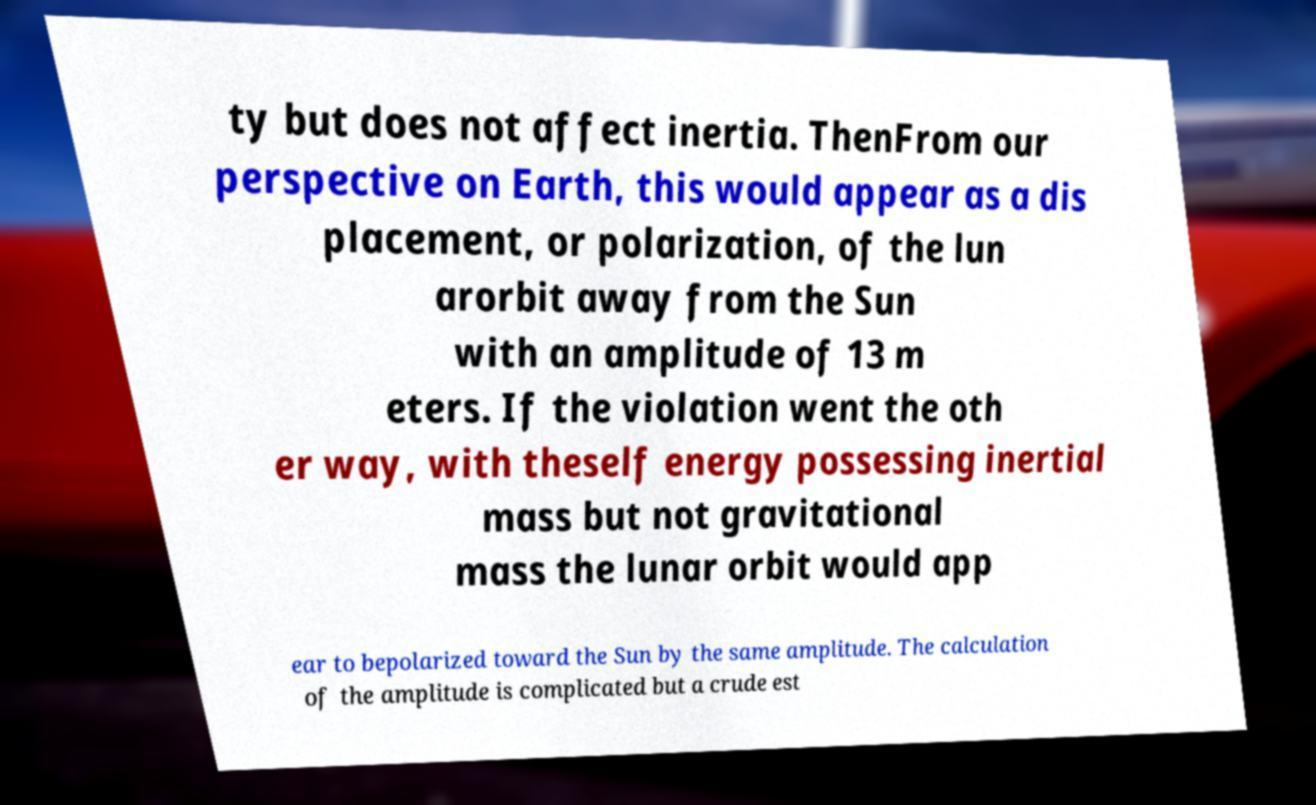For documentation purposes, I need the text within this image transcribed. Could you provide that? ty but does not affect inertia. ThenFrom our perspective on Earth, this would appear as a dis placement, or polarization, of the lun arorbit away from the Sun with an amplitude of 13 m eters. If the violation went the oth er way, with theself energy possessing inertial mass but not gravitational mass the lunar orbit would app ear to bepolarized toward the Sun by the same amplitude. The calculation of the amplitude is complicated but a crude est 